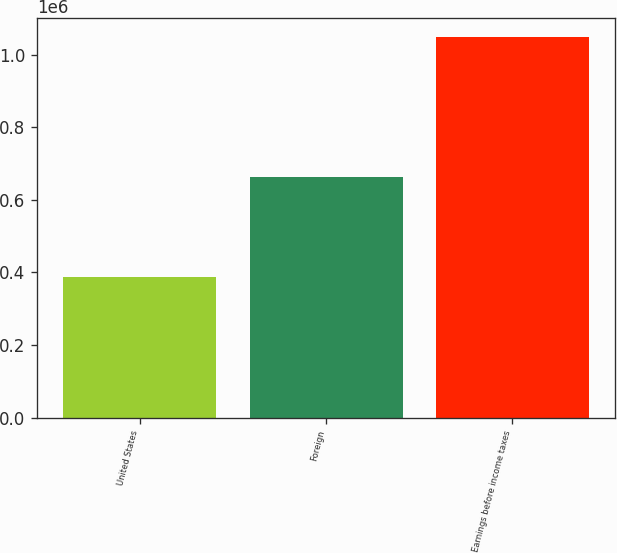<chart> <loc_0><loc_0><loc_500><loc_500><bar_chart><fcel>United States<fcel>Foreign<fcel>Earnings before income taxes<nl><fcel>387564<fcel>661637<fcel>1.0492e+06<nl></chart> 